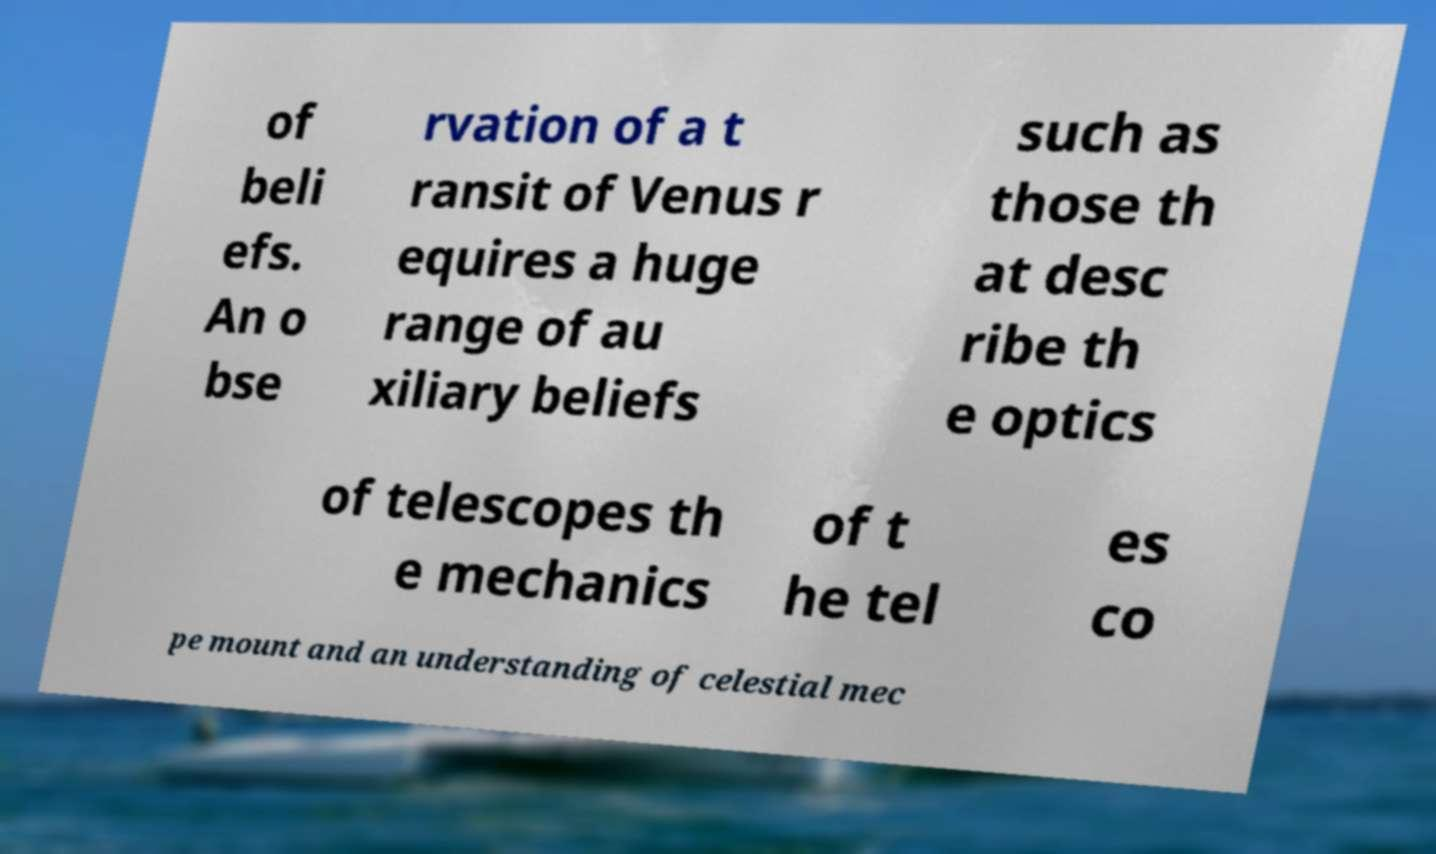Could you assist in decoding the text presented in this image and type it out clearly? of beli efs. An o bse rvation of a t ransit of Venus r equires a huge range of au xiliary beliefs such as those th at desc ribe th e optics of telescopes th e mechanics of t he tel es co pe mount and an understanding of celestial mec 